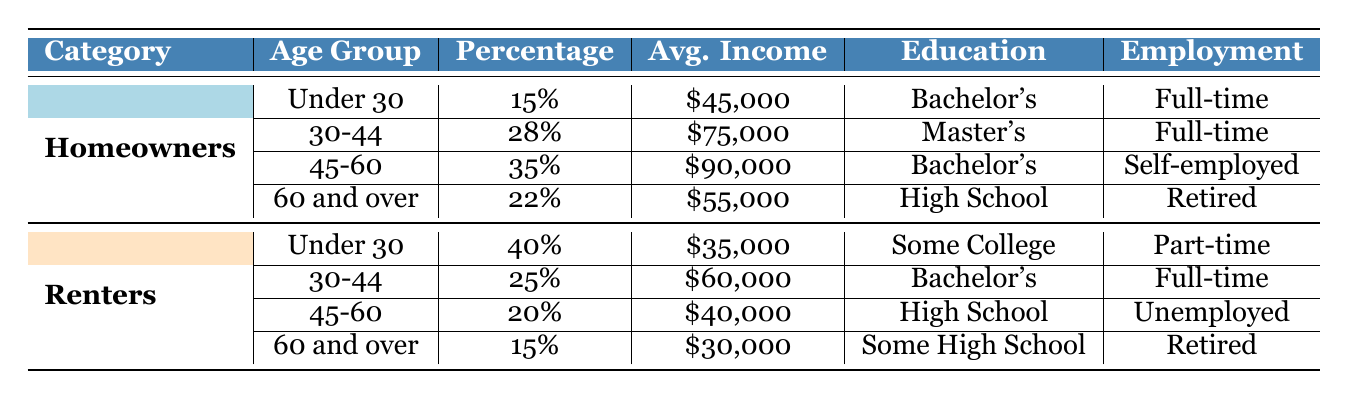What percentage of homeowners are aged 30-44? The table indicates that 28% of homeowners fall within the age group of 30-44.
Answer: 28% What is the average income of renters aged 45-60? Referring to the table, renters aged 45-60 have an average income of $40,000.
Answer: $40,000 Are there more homeowners or renters in the age group of 60 and over? Homeowners make up 22% in the age group of 60 and over, while renters account for 15%. Thus, there are more homeowners in this age group.
Answer: Yes, more homeowners What percentage of renters have a college education? According to the data, 40% of renters aged under 30 have some college education, 25% are bachelor degree holders in the 30-44 age group, totaling 65%.
Answer: 65% What is the difference in average income between homeowners and renters aged under 30? Homeowners aged under 30 have an average income of $45,000, whereas renters in the same age group have an average income of $35,000. The difference is $45,000 - $35,000 = $10,000.
Answer: $10,000 How many homeowners have a Master’s degree? Based on the table, the only age group of homeowners with a Master's degree is those aged 30-44, making it 28%.
Answer: 28% What is the median average income of homeowners compared to renters? The average income of homeowners is ($45,000 + $75,000 + $90,000 + $55,000) / 4 = $66,250. For renters, it's ($35,000 + $60,000 + $40,000 + $30,000) / 4 = $41,250. The median difference is $66,250 - $41,250 = $25,000.
Answer: $25,000 Which age group has the highest percentage of homeowners? From the table, the age group 45-60 has the highest percentage of homeowners at 35%.
Answer: 45-60 Are retirees more likely to be homeowners or renters? Homeowners aged 60 and over are retired, making up 22%, while renters aged 60 and over account for 15%. More retirees are homeowners.
Answer: Yes, more homeowners What is the ratio of homeowners to renters in the age group of 30-44? There are 28% homeowners and 25% renters in this group. The ratio is 28:25.
Answer: 28:25 